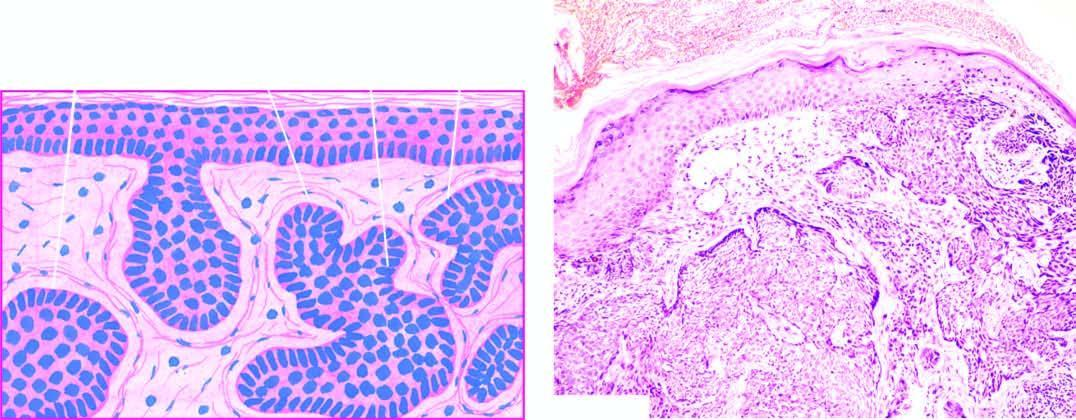s peripheral blood in itp invaded by irregular masses of basaloid cells with characteristic peripheral palisaded appearance?
Answer the question using a single word or phrase. No 